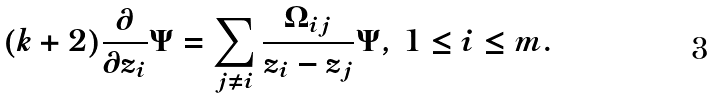Convert formula to latex. <formula><loc_0><loc_0><loc_500><loc_500>( k + 2 ) \frac { \partial } { \partial z _ { i } } \Psi = \sum _ { j \neq i } \frac { \Omega _ { i j } } { z _ { i } - z _ { j } } \Psi , \, 1 \leq i \leq m .</formula> 